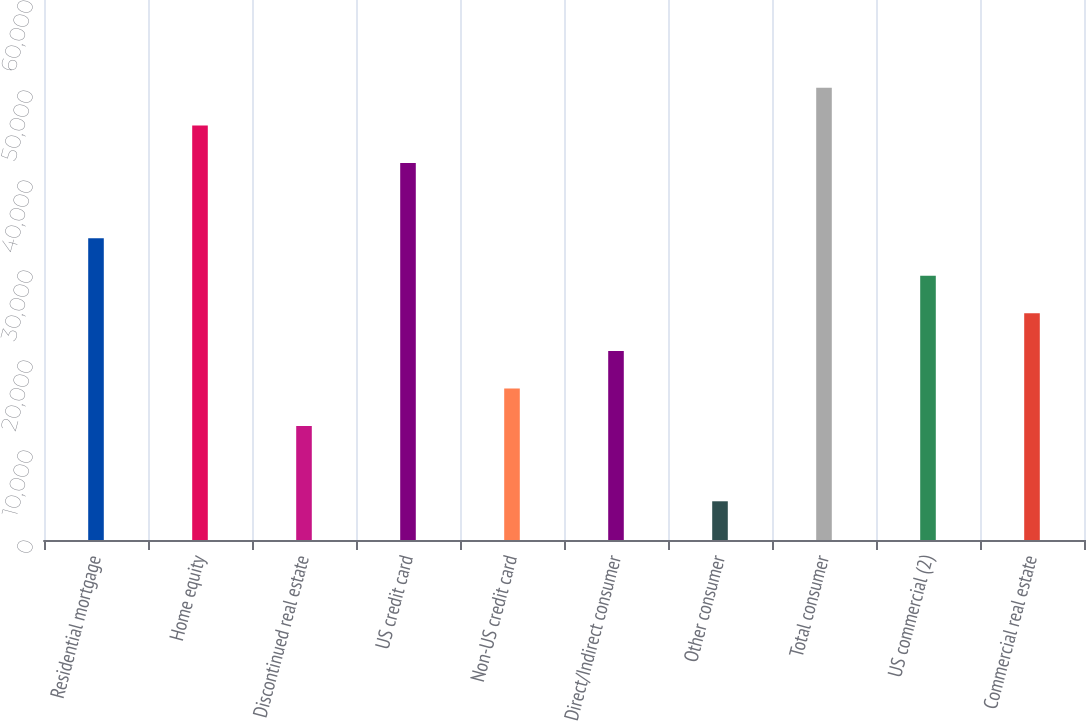Convert chart to OTSL. <chart><loc_0><loc_0><loc_500><loc_500><bar_chart><fcel>Residential mortgage<fcel>Home equity<fcel>Discontinued real estate<fcel>US credit card<fcel>Non-US credit card<fcel>Direct/Indirect consumer<fcel>Other consumer<fcel>Total consumer<fcel>US commercial (2)<fcel>Commercial real estate<nl><fcel>33533.2<fcel>46060.9<fcel>12653.7<fcel>41885<fcel>16829.6<fcel>21005.5<fcel>4301.9<fcel>50236.8<fcel>29357.3<fcel>25181.4<nl></chart> 